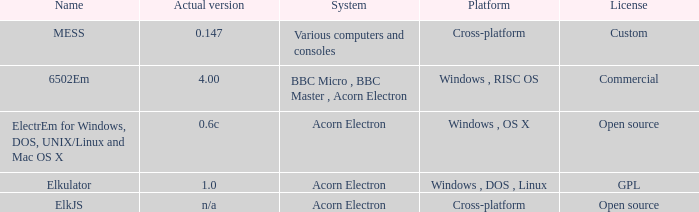What is the system called elkjs? Acorn Electron. 